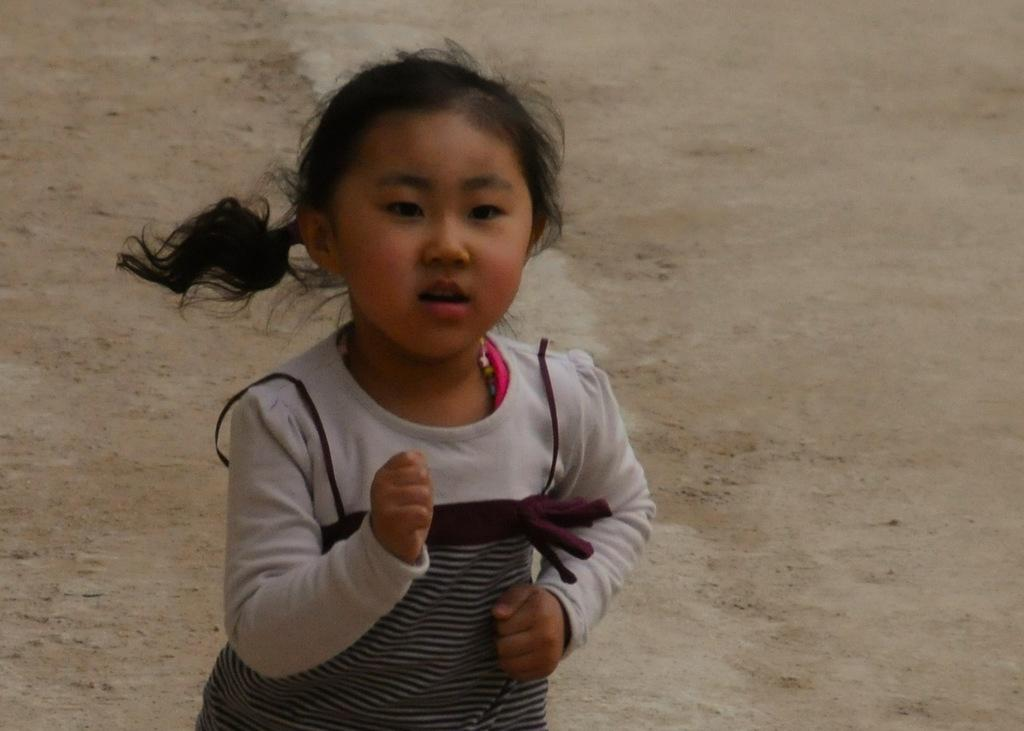Where was the image taken? The image was clicked outside. Who is present in the image? There is a girl in the image. What is the girl wearing? The girl is wearing a white T-shirt. What is the girl doing in the image? The girl appears to be running on the ground. Can you see a kitten trying to get the girl's attention in the image? There is no kitten present in the image, and therefore no such interaction can be observed. 